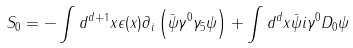<formula> <loc_0><loc_0><loc_500><loc_500>S _ { 0 } = - \int d ^ { d + 1 } x \epsilon ( x ) \partial _ { i } \left ( \bar { \psi } \gamma ^ { 0 } \gamma _ { 5 } \psi \right ) + \int d ^ { d } x \bar { \psi } i \gamma ^ { 0 } D _ { 0 } \psi</formula> 